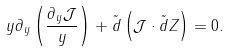Convert formula to latex. <formula><loc_0><loc_0><loc_500><loc_500>y \partial _ { y } \left ( \frac { \partial _ { y } \mathcal { J } } { y } \right ) + \tilde { d } \left ( \mathcal { J } \cdot \tilde { d } Z \right ) = 0 .</formula> 